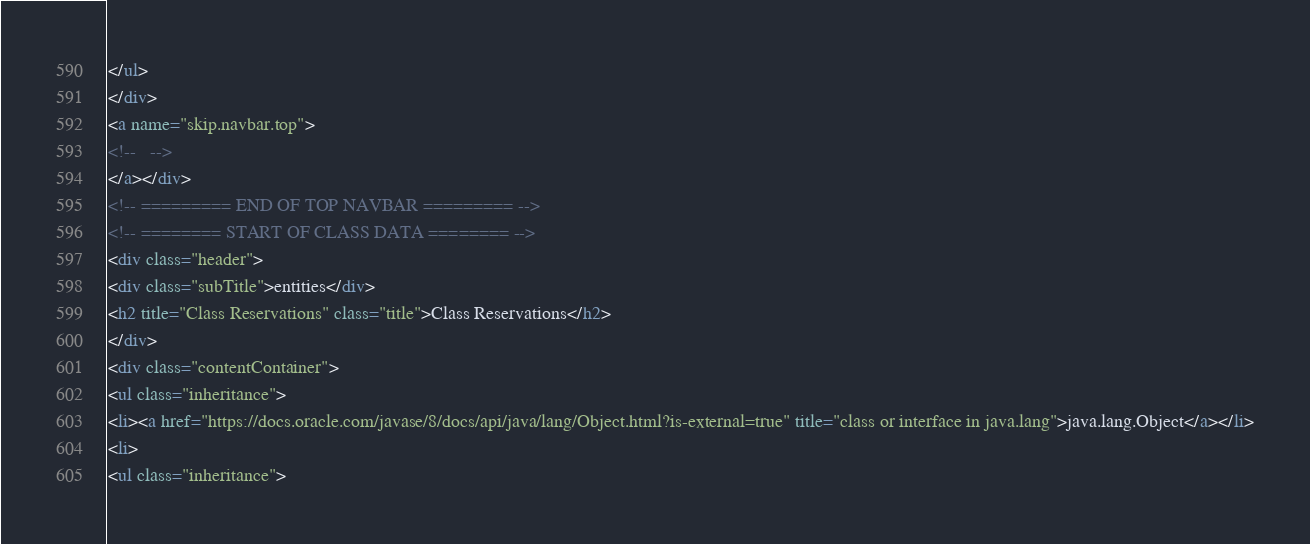Convert code to text. <code><loc_0><loc_0><loc_500><loc_500><_HTML_></ul>
</div>
<a name="skip.navbar.top">
<!--   -->
</a></div>
<!-- ========= END OF TOP NAVBAR ========= -->
<!-- ======== START OF CLASS DATA ======== -->
<div class="header">
<div class="subTitle">entities</div>
<h2 title="Class Reservations" class="title">Class Reservations</h2>
</div>
<div class="contentContainer">
<ul class="inheritance">
<li><a href="https://docs.oracle.com/javase/8/docs/api/java/lang/Object.html?is-external=true" title="class or interface in java.lang">java.lang.Object</a></li>
<li>
<ul class="inheritance"></code> 